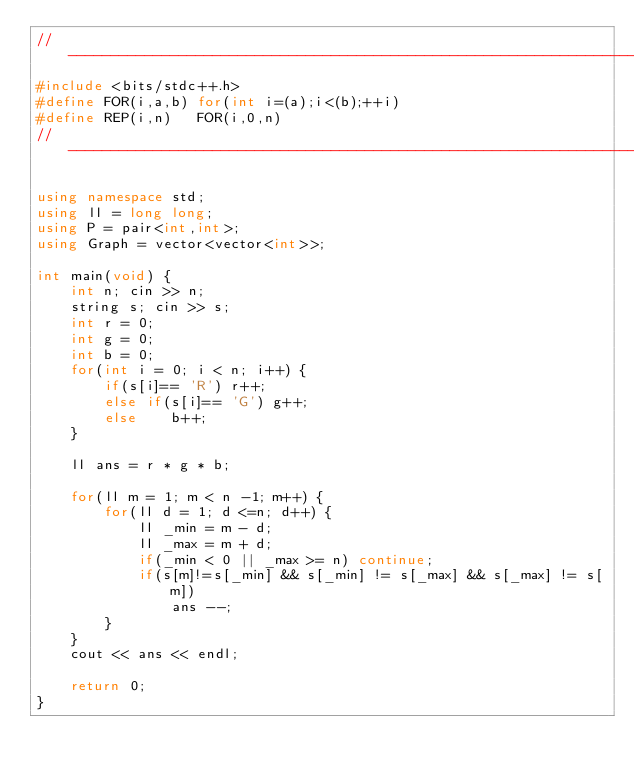<code> <loc_0><loc_0><loc_500><loc_500><_C++_>//----------------------------------------------------------------------
#include <bits/stdc++.h>
#define FOR(i,a,b) for(int i=(a);i<(b);++i)
#define REP(i,n)   FOR(i,0,n)
//----------------------------------------------------------------------

using namespace std;
using ll = long long;
using P = pair<int,int>;
using Graph = vector<vector<int>>;

int main(void) {
    int n; cin >> n;
    string s; cin >> s;
    int r = 0;
    int g = 0;
    int b = 0;
    for(int i = 0; i < n; i++) {
        if(s[i]== 'R') r++;
        else if(s[i]== 'G') g++;
        else    b++;
    }

    ll ans = r * g * b;

    for(ll m = 1; m < n -1; m++) {
        for(ll d = 1; d <=n; d++) {
            ll _min = m - d;
            ll _max = m + d;
            if(_min < 0 || _max >= n) continue;
            if(s[m]!=s[_min] && s[_min] != s[_max] && s[_max] != s[m])
                ans --;
        }
    }
    cout << ans << endl;

    return 0;
}</code> 